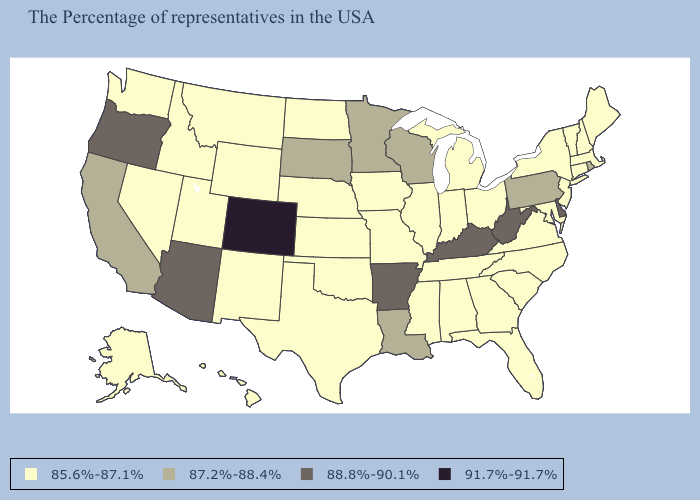Does South Dakota have the lowest value in the MidWest?
Answer briefly. No. Name the states that have a value in the range 87.2%-88.4%?
Keep it brief. Rhode Island, Pennsylvania, Wisconsin, Louisiana, Minnesota, South Dakota, California. How many symbols are there in the legend?
Concise answer only. 4. Name the states that have a value in the range 88.8%-90.1%?
Be succinct. Delaware, West Virginia, Kentucky, Arkansas, Arizona, Oregon. Name the states that have a value in the range 87.2%-88.4%?
Be succinct. Rhode Island, Pennsylvania, Wisconsin, Louisiana, Minnesota, South Dakota, California. Among the states that border Maryland , does Virginia have the lowest value?
Write a very short answer. Yes. What is the highest value in the USA?
Keep it brief. 91.7%-91.7%. How many symbols are there in the legend?
Write a very short answer. 4. Which states have the lowest value in the USA?
Keep it brief. Maine, Massachusetts, New Hampshire, Vermont, Connecticut, New York, New Jersey, Maryland, Virginia, North Carolina, South Carolina, Ohio, Florida, Georgia, Michigan, Indiana, Alabama, Tennessee, Illinois, Mississippi, Missouri, Iowa, Kansas, Nebraska, Oklahoma, Texas, North Dakota, Wyoming, New Mexico, Utah, Montana, Idaho, Nevada, Washington, Alaska, Hawaii. Among the states that border Louisiana , which have the lowest value?
Short answer required. Mississippi, Texas. Name the states that have a value in the range 91.7%-91.7%?
Give a very brief answer. Colorado. Does Illinois have the lowest value in the USA?
Write a very short answer. Yes. Does the first symbol in the legend represent the smallest category?
Keep it brief. Yes. Does Vermont have the same value as Oregon?
Be succinct. No. Among the states that border West Virginia , which have the highest value?
Write a very short answer. Kentucky. 